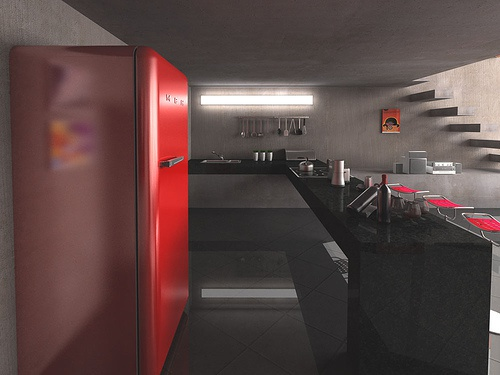Describe the objects in this image and their specific colors. I can see refrigerator in gray, maroon, brown, and red tones, bottle in gray, black, maroon, and darkgray tones, chair in gray, red, brown, and salmon tones, chair in gray, red, and darkgray tones, and cup in gray, white, maroon, and black tones in this image. 